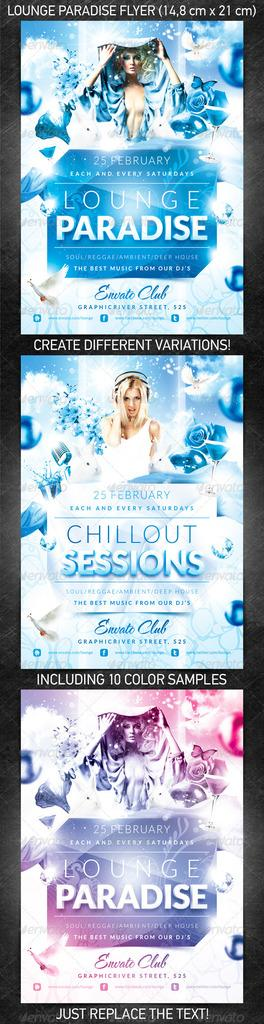<image>
Offer a succinct explanation of the picture presented. An event poster promotes Lounge Paradise and Chillout Sessions. 